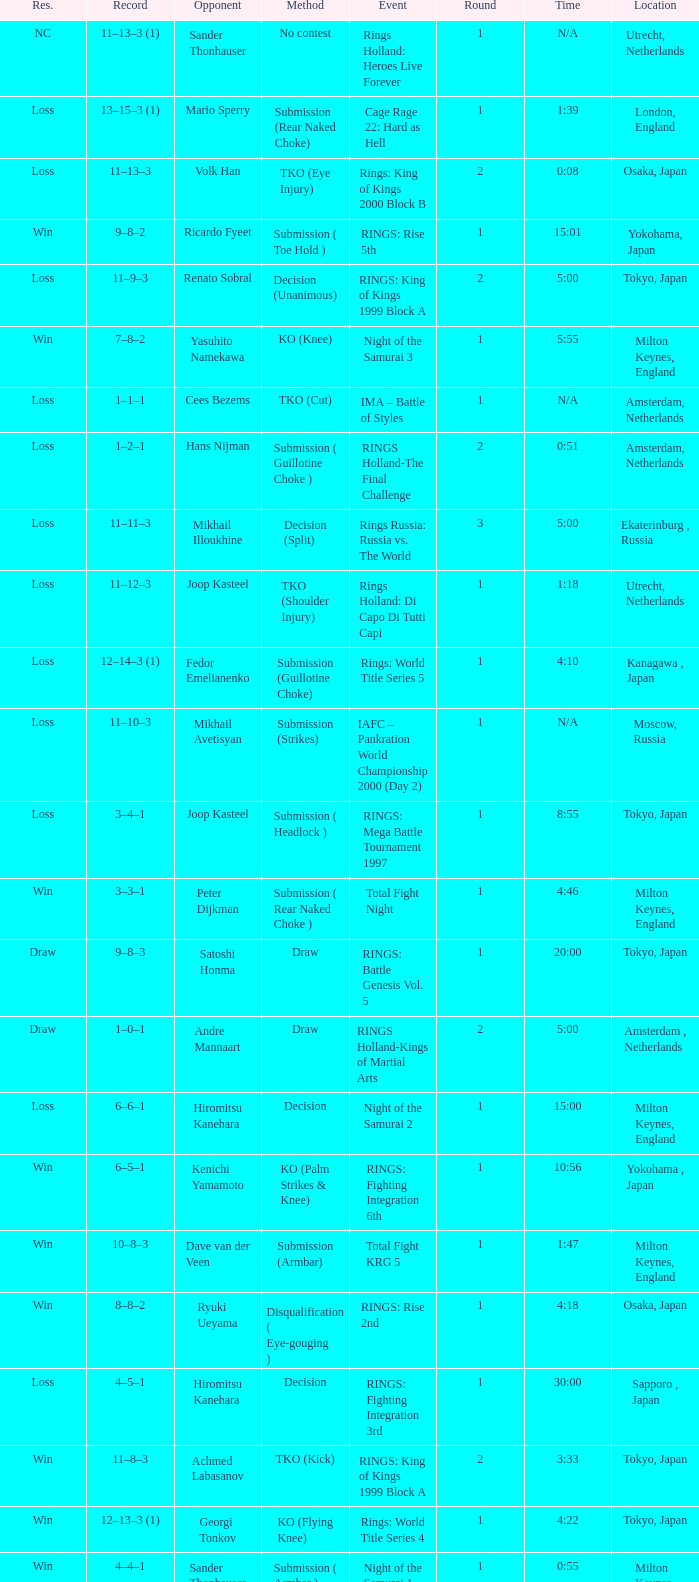What was the method for opponent of Ivan Serati? Submission (Rear Naked Choke). 